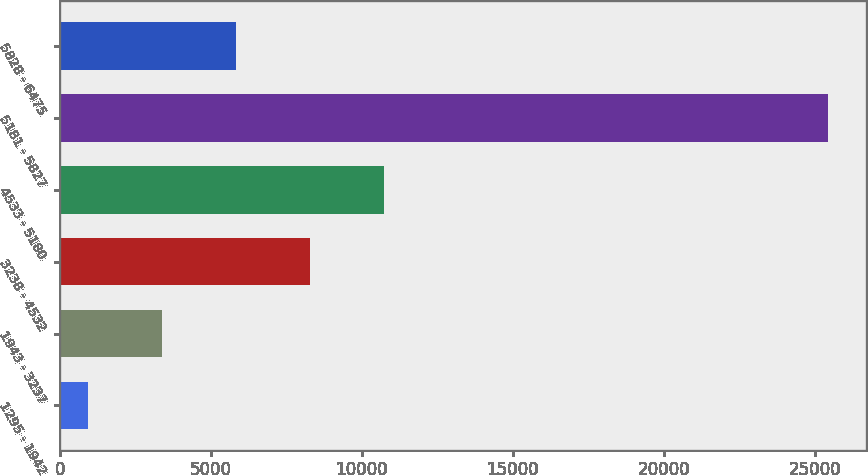Convert chart to OTSL. <chart><loc_0><loc_0><loc_500><loc_500><bar_chart><fcel>1295 - 1942<fcel>1943 - 3237<fcel>3238 - 4532<fcel>4533 - 5180<fcel>5181 - 5827<fcel>5828 - 6475<nl><fcel>948<fcel>3397.5<fcel>8296.5<fcel>10746<fcel>25443<fcel>5847<nl></chart> 